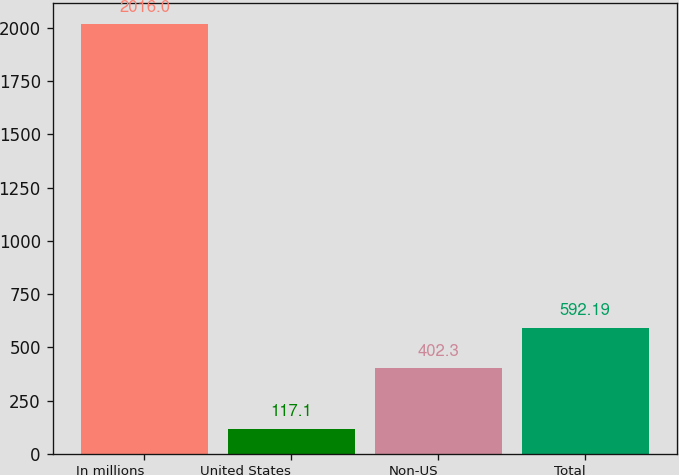<chart> <loc_0><loc_0><loc_500><loc_500><bar_chart><fcel>In millions<fcel>United States<fcel>Non-US<fcel>Total<nl><fcel>2016<fcel>117.1<fcel>402.3<fcel>592.19<nl></chart> 